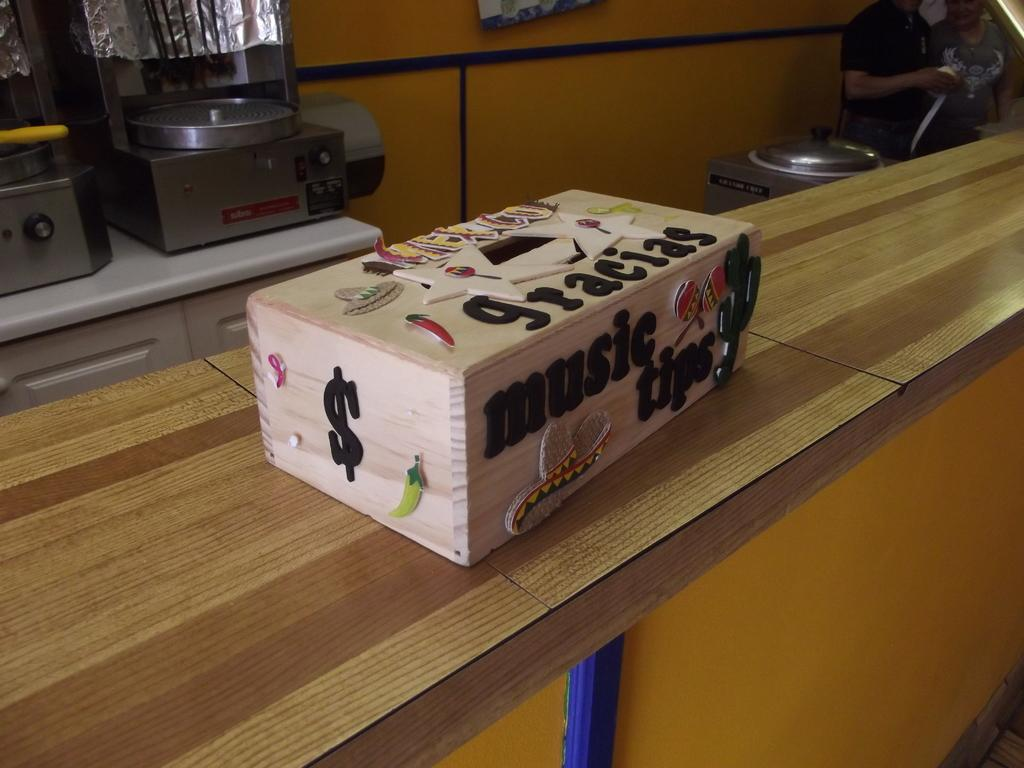<image>
Present a compact description of the photo's key features. A rectangular beige box has music tips and gracias on it in the type of letters that are often glued on. 